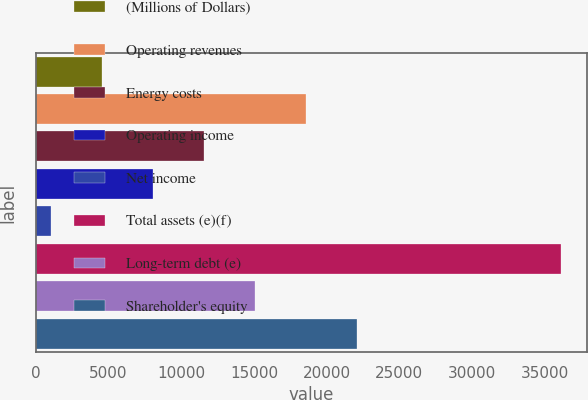<chart> <loc_0><loc_0><loc_500><loc_500><bar_chart><fcel>(Millions of Dollars)<fcel>Operating revenues<fcel>Energy costs<fcel>Operating income<fcel>Net income<fcel>Total assets (e)(f)<fcel>Long-term debt (e)<fcel>Shareholder's equity<nl><fcel>4527.5<fcel>18557.5<fcel>11542.5<fcel>8035<fcel>1020<fcel>36095<fcel>15050<fcel>22065<nl></chart> 